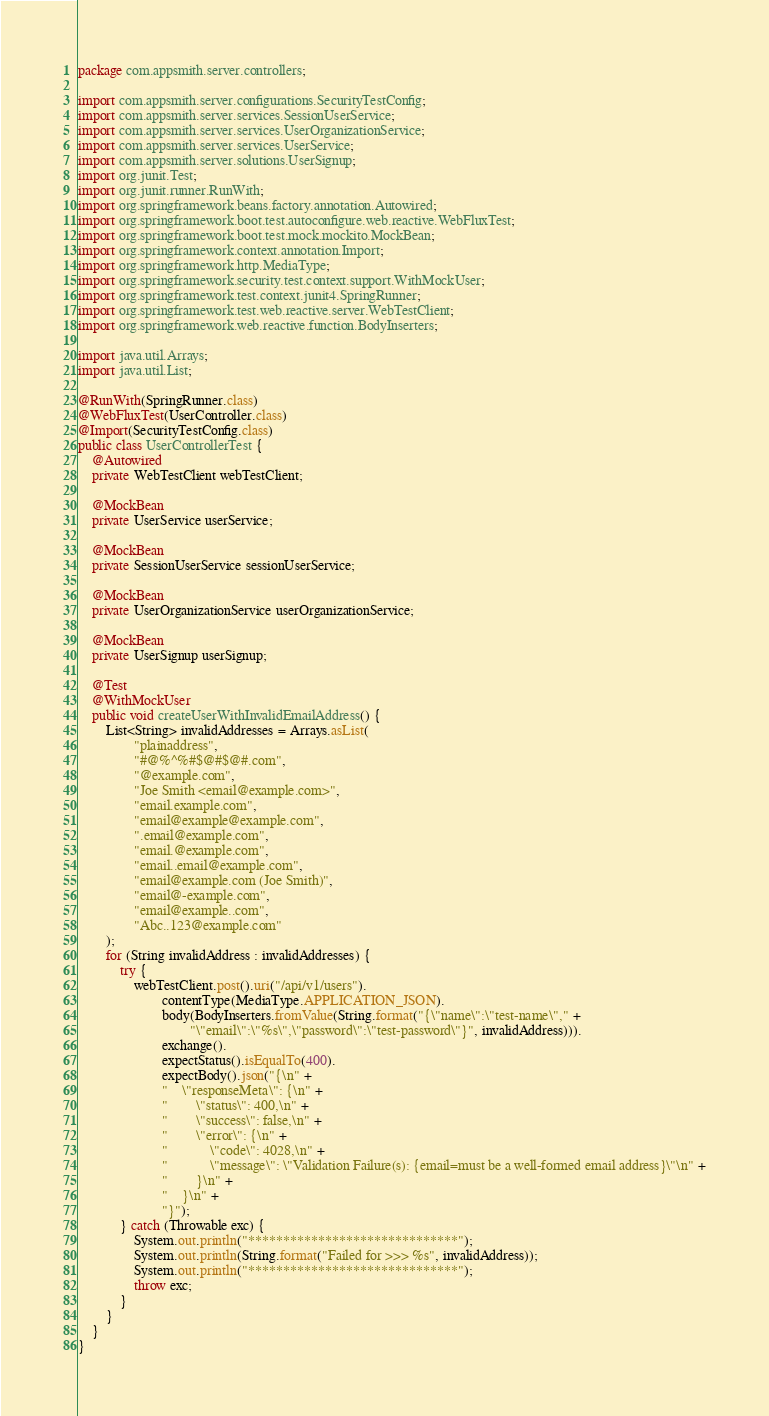<code> <loc_0><loc_0><loc_500><loc_500><_Java_>package com.appsmith.server.controllers;

import com.appsmith.server.configurations.SecurityTestConfig;
import com.appsmith.server.services.SessionUserService;
import com.appsmith.server.services.UserOrganizationService;
import com.appsmith.server.services.UserService;
import com.appsmith.server.solutions.UserSignup;
import org.junit.Test;
import org.junit.runner.RunWith;
import org.springframework.beans.factory.annotation.Autowired;
import org.springframework.boot.test.autoconfigure.web.reactive.WebFluxTest;
import org.springframework.boot.test.mock.mockito.MockBean;
import org.springframework.context.annotation.Import;
import org.springframework.http.MediaType;
import org.springframework.security.test.context.support.WithMockUser;
import org.springframework.test.context.junit4.SpringRunner;
import org.springframework.test.web.reactive.server.WebTestClient;
import org.springframework.web.reactive.function.BodyInserters;

import java.util.Arrays;
import java.util.List;

@RunWith(SpringRunner.class)
@WebFluxTest(UserController.class)
@Import(SecurityTestConfig.class)
public class UserControllerTest {
    @Autowired
    private WebTestClient webTestClient;

    @MockBean
    private UserService userService;

    @MockBean
    private SessionUserService sessionUserService;

    @MockBean
    private UserOrganizationService userOrganizationService;

    @MockBean
    private UserSignup userSignup;

    @Test
    @WithMockUser
    public void createUserWithInvalidEmailAddress() {
        List<String> invalidAddresses = Arrays.asList(
                "plainaddress",
                "#@%^%#$@#$@#.com",
                "@example.com",
                "Joe Smith <email@example.com>",
                "email.example.com",
                "email@example@example.com",
                ".email@example.com",
                "email.@example.com",
                "email..email@example.com",
                "email@example.com (Joe Smith)",
                "email@-example.com",
                "email@example..com",
                "Abc..123@example.com"
        );
        for (String invalidAddress : invalidAddresses) {
            try {
                webTestClient.post().uri("/api/v1/users").
                        contentType(MediaType.APPLICATION_JSON).
                        body(BodyInserters.fromValue(String.format("{\"name\":\"test-name\"," +
                                "\"email\":\"%s\",\"password\":\"test-password\"}", invalidAddress))).
                        exchange().
                        expectStatus().isEqualTo(400).
                        expectBody().json("{\n" +
                        "    \"responseMeta\": {\n" +
                        "        \"status\": 400,\n" +
                        "        \"success\": false,\n" +
                        "        \"error\": {\n" +
                        "            \"code\": 4028,\n" +
                        "            \"message\": \"Validation Failure(s): {email=must be a well-formed email address}\"\n" +
                        "        }\n" +
                        "    }\n" +
                        "}");
            } catch (Throwable exc) {
                System.out.println("******************************");
                System.out.println(String.format("Failed for >>> %s", invalidAddress));
                System.out.println("******************************");
                throw exc;
            }
        }
    }
}
</code> 